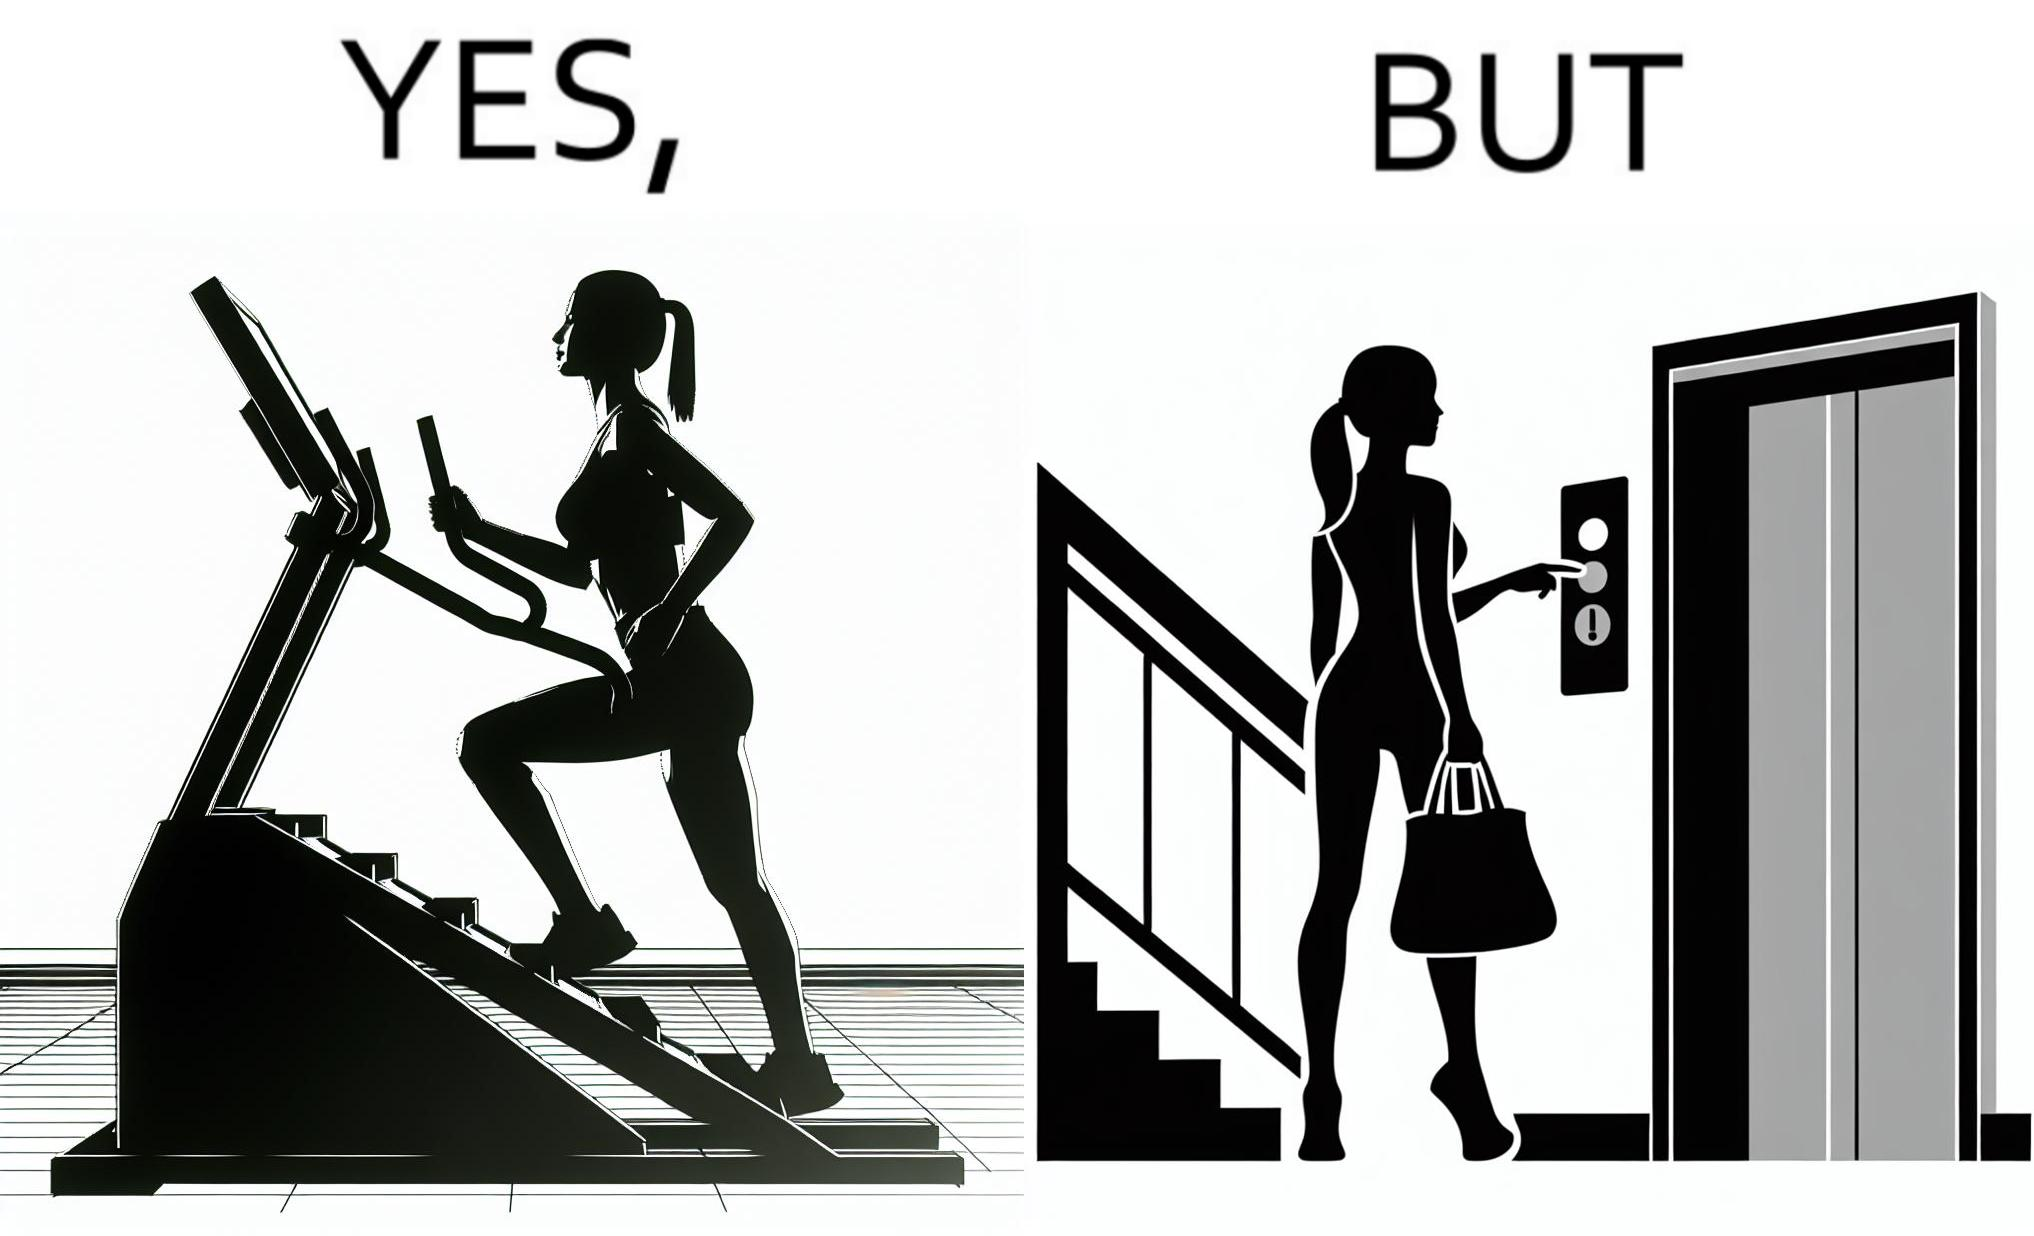What do you see in each half of this image? In the left part of the image: a woman is seen using the stair climber machine at some gym In the right part of the image: a woman calling for the lift to avoid climbing up the stairs for going to the gym 